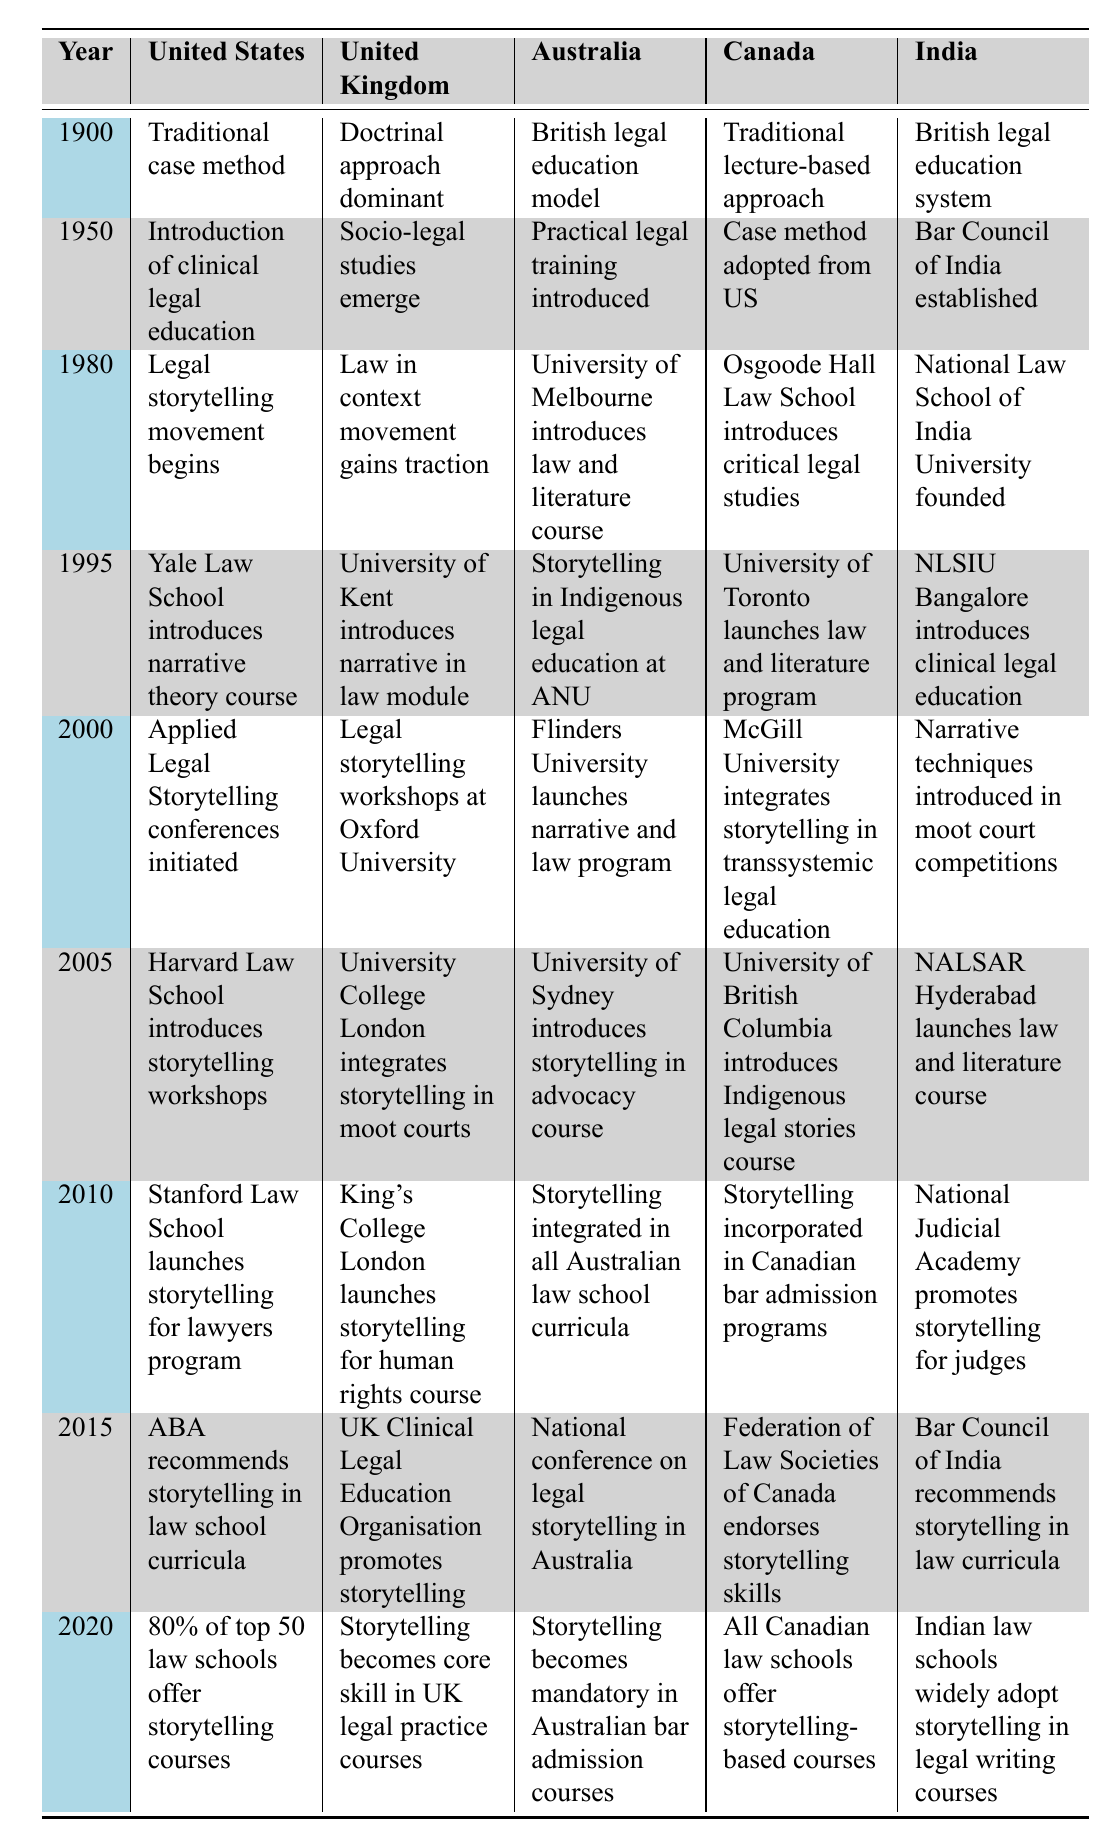What year did storytelling begin to be integrated into Canadian law schools? According to the table, storytelling was incorporated into Canadian bar admission programs in 2010, which indicates that this is likely when integration into law schools began.
Answer: 2010 Which country first introduced legal storytelling courses in the year 2000? The table shows that in 2000, applied legal storytelling conferences were initiated in the United States. This implies that the U.S. was the country that first introduced legal storytelling courses at that time.
Answer: United States In which year did the UK and Australia both introduce courses related to storytelling? The table indicates that both the UK and Australia introduced relevant courses in 2005. Specifically, this is when University College London integrated storytelling in moot courts in the UK, and in Australia, the University of Sydney introduced a storytelling in advocacy course.
Answer: 2005 Was the narrative theory course introduced earlier in Yale Law School or the law and literature program at the University of Toronto? According to the table, Yale Law School introduced the narrative theory course in 1995, while the University of Toronto launched the law and literature program in 2000. Therefore, the narrative theory course was introduced first.
Answer: Yes How many countries included storytelling in their legal curricula by the year 2020? From the table, by 2020 all five countries listed (United States, United Kingdom, Australia, Canada, and India) included storytelling in their legal curricula. Therefore, the total is five.
Answer: 5 What trend can be observed regarding storytelling in law education across the table years? Observing the table, storytelling began to integrate into legal education practices starting in the 1980s, and by 2020, storytelling had become a common component in law curricula across multiple countries, indicating a significant trend towards recognizing its importance.
Answer: Integration trend towards importance What position does storytelling hold in the curricula of the top 50 law schools in the United States by 2020? The table states that by 2020, 80% of the top 50 law schools in the United States offered courses in storytelling, demonstrating its established position within these curricula.
Answer: 80% In how many regions outside the United States are storytelling skills promoted in legal education by 2015? The table shows that by 2015, storytelling skills were explicitly promoted in the United Kingdom, Australia, Canada, and India, totaling four regions outside the United States that had initiatives related to storytelling in legal education.
Answer: 4 Is there evidence of storytelling being recognized as a necessary skill in legal practice by 2020 in the UK? Yes, the table indicates that by 2020, storytelling had become a core skill in UK legal practice courses, confirming its recognition as necessary in that region.
Answer: Yes Which country had a national conference on legal storytelling, and when did it occur? According to the data, Australia held a national conference on legal storytelling in 2015, as noted in the relevant cell in the table.
Answer: 2015 